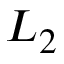Convert formula to latex. <formula><loc_0><loc_0><loc_500><loc_500>L _ { 2 }</formula> 